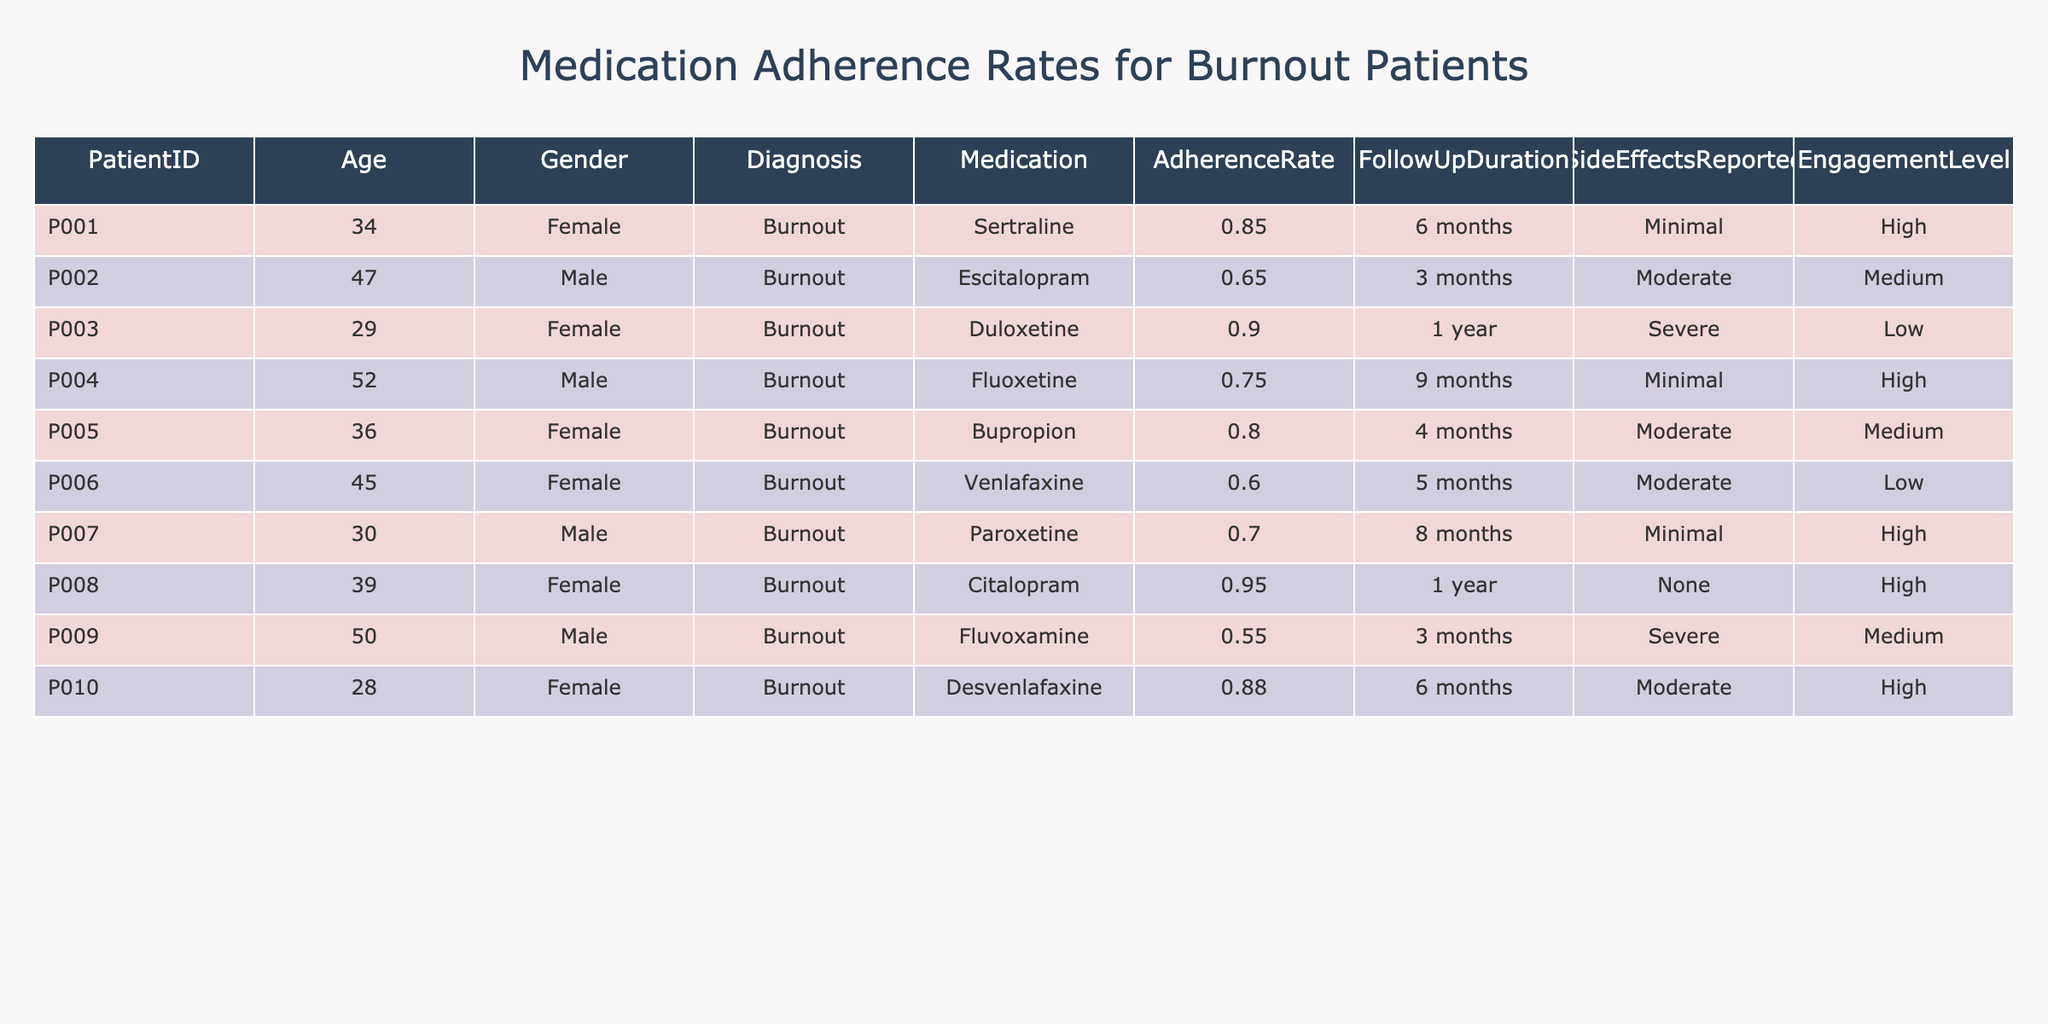What is the adherence rate for patient P008? The adherence rate is directly listed in the table under the column for adherence rates. For patient P008, it is noted as 0.95.
Answer: 0.95 How many patients reported severe side effects? To find this, we look at the "SideEffectsReported" column and count the instances of "Severe." There are two patients (P003 and P009) who reported severe side effects.
Answer: 2 What is the average adherence rate for the patients prescribed Sertraline and Duloxetine? First, we identify the adherence rates for both medications: Sertraline has an adherence rate of 0.85 and Duloxetine has 0.90. Next, we calculate the average: (0.85 + 0.90) / 2 = 0.875.
Answer: 0.875 Is there a patient who has both high engagement level and high adherence rate? We check the engagement level and adherence rate for each patient. Patient P008, who takes Citalopram, meets both criteria with an adherence rate of 0.95 and a high engagement level.
Answer: Yes Which medication has the highest adherence rate and what is that rate? We review the adherence rates listed for each medication and determine that Citalopram has the highest adherence rate at 0.95.
Answer: Citalopram, 0.95 What is the difference in adherence rates between patients P010 and P006? The adherence rate for P010 is 0.88 and for P006 it is 0.60. The difference is calculated as 0.88 - 0.60 = 0.28.
Answer: 0.28 Are there more male patients than female patients with adherence rates above 0.75? Analyzing the table, we find that two male patients (P001, P004) and three female patients (P003, P008, P010) have adherence rates above 0.75. Thus, there are more female patients.
Answer: No What percentage of patients reported only minimal side effects? We check the side effects reported for all patients. There are four patients (P001, P004, P007) who reported minimal side effects out of ten total patients, which gives us (4/10) * 100 = 40%.
Answer: 40% Which patient has the lowest adherence rate and what is it? By reviewing the adherence rates, we see that patient P009 has the lowest rate at 0.55.
Answer: P009, 0.55 How does the average adherence rate of male patients compare to that of female patients? We sum the adherence rates for male patients (0.65 + 0.75 + 0.60 + 0.70 + 0.55) = 3.55 and for female patients (0.85 + 0.90 + 0.80 + 0.95 + 0.88) = 4.38. The averages are 3.55/5 = 0.71 and 4.38/5 = 0.876, respectively. The averages show that female patients have a higher adherence rate.
Answer: Female patients have a higher average adherence rate 